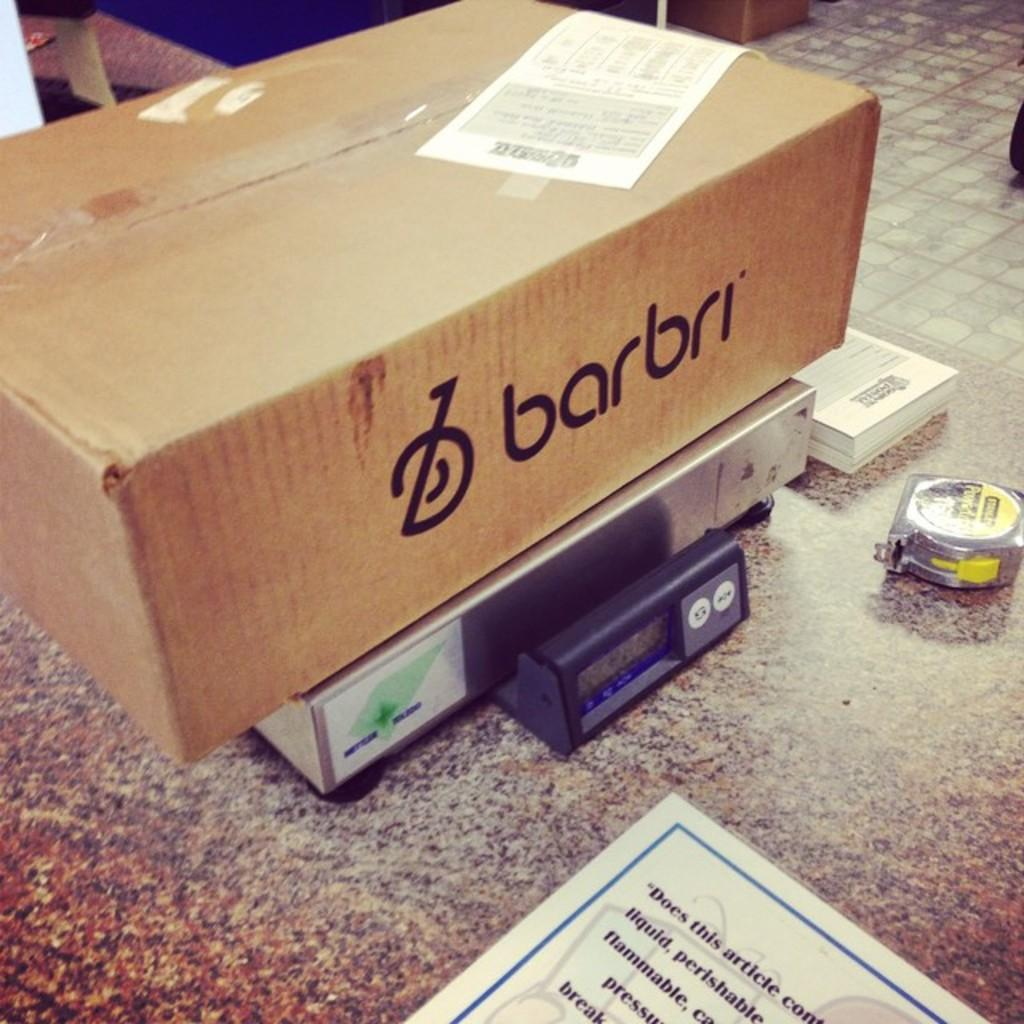<image>
Present a compact description of the photo's key features. A box labeled Barbri sits on a postage scale. 